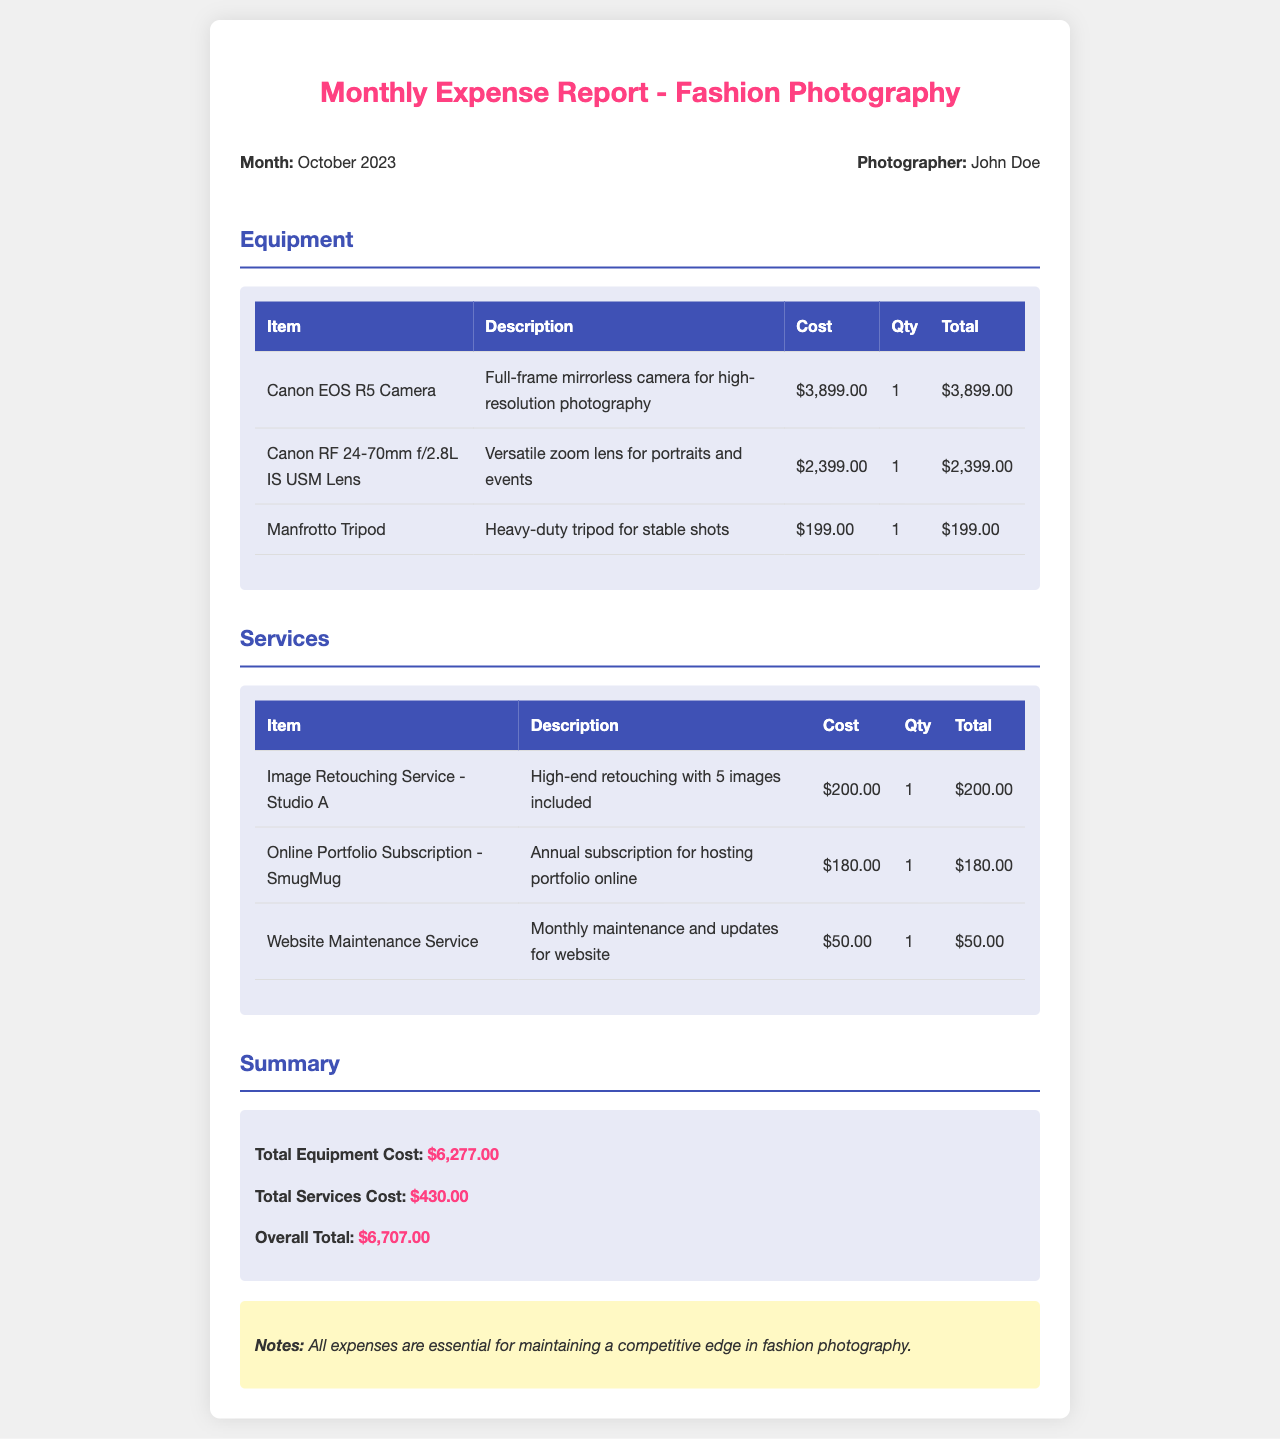What is the month of the expense report? The month of the expense report is indicated clearly at the beginning of the document, which is October 2023.
Answer: October 2023 Who is the photographer? The photographer's name is provided in the document, which is John Doe.
Answer: John Doe What is the total cost of equipment? The total cost of equipment is calculated and stated in the summary section of the document, which is $6,277.00.
Answer: $6,277.00 How many Canon RF 24-70mm f/2.8L IS USM Lens were purchased? The quantity of Canon RF 24-70mm f/2.8L IS USM Lens is specified in the equipment table as 1.
Answer: 1 What is the cost of the Image Retouching Service? The cost of the Image Retouching Service is given in the services table as $200.00.
Answer: $200.00 What is the overall total expense for October 2023? The overall total expense is presented in the summary section, calculated from both equipment and services costs, which is $6,707.00.
Answer: $6,707.00 What is the description for Manfrotto Tripod? The description for Manfrotto Tripod is provided in the equipment table as "Heavy-duty tripod for stable shots."
Answer: Heavy-duty tripod for stable shots How many images are included in the Image Retouching Service? The number of images included in the Image Retouching Service is mentioned in the services table, which is 5.
Answer: 5 What type of subscription is included in the services? The type of subscription mentioned in the services section is for "Online Portfolio Subscription - SmugMug."
Answer: Online Portfolio Subscription - SmugMug 